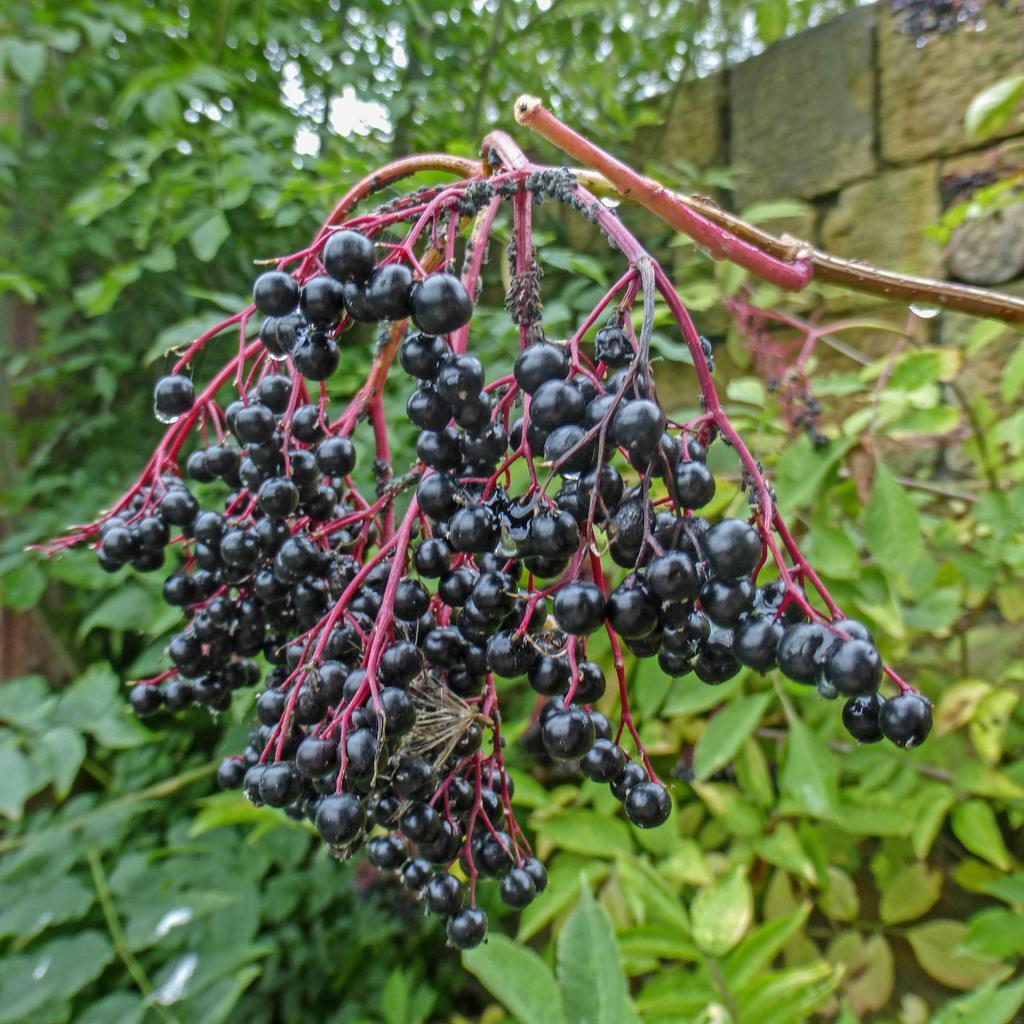In one or two sentences, can you explain what this image depicts? In the center of the image we can see berries to the tree. In the background there are trees and we can see a wall. 